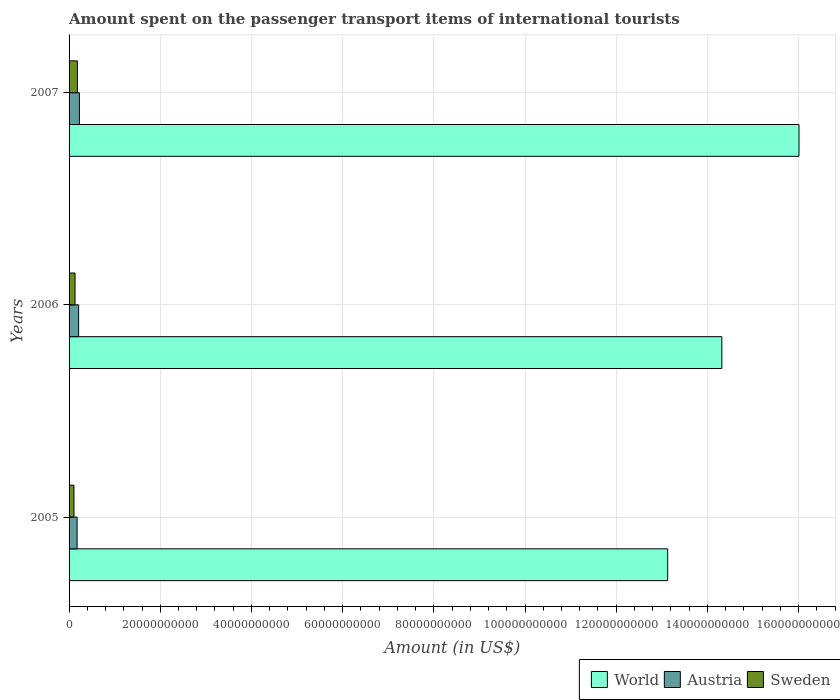How many groups of bars are there?
Give a very brief answer. 3. Are the number of bars per tick equal to the number of legend labels?
Give a very brief answer. Yes. Are the number of bars on each tick of the Y-axis equal?
Provide a short and direct response. Yes. How many bars are there on the 1st tick from the bottom?
Offer a very short reply. 3. In how many cases, is the number of bars for a given year not equal to the number of legend labels?
Ensure brevity in your answer.  0. What is the amount spent on the passenger transport items of international tourists in World in 2006?
Keep it short and to the point. 1.43e+11. Across all years, what is the maximum amount spent on the passenger transport items of international tourists in World?
Your answer should be very brief. 1.60e+11. Across all years, what is the minimum amount spent on the passenger transport items of international tourists in World?
Keep it short and to the point. 1.31e+11. In which year was the amount spent on the passenger transport items of international tourists in Sweden maximum?
Make the answer very short. 2007. What is the total amount spent on the passenger transport items of international tourists in World in the graph?
Your response must be concise. 4.35e+11. What is the difference between the amount spent on the passenger transport items of international tourists in World in 2006 and that in 2007?
Make the answer very short. -1.69e+1. What is the difference between the amount spent on the passenger transport items of international tourists in Sweden in 2005 and the amount spent on the passenger transport items of international tourists in World in 2007?
Make the answer very short. -1.59e+11. What is the average amount spent on the passenger transport items of international tourists in World per year?
Ensure brevity in your answer.  1.45e+11. In the year 2005, what is the difference between the amount spent on the passenger transport items of international tourists in Austria and amount spent on the passenger transport items of international tourists in Sweden?
Offer a terse response. 6.87e+08. In how many years, is the amount spent on the passenger transport items of international tourists in Sweden greater than 100000000000 US$?
Provide a succinct answer. 0. What is the ratio of the amount spent on the passenger transport items of international tourists in World in 2005 to that in 2007?
Offer a very short reply. 0.82. What is the difference between the highest and the second highest amount spent on the passenger transport items of international tourists in World?
Ensure brevity in your answer.  1.69e+1. What is the difference between the highest and the lowest amount spent on the passenger transport items of international tourists in Austria?
Make the answer very short. 5.03e+08. Is the sum of the amount spent on the passenger transport items of international tourists in Austria in 2006 and 2007 greater than the maximum amount spent on the passenger transport items of international tourists in Sweden across all years?
Ensure brevity in your answer.  Yes. Is it the case that in every year, the sum of the amount spent on the passenger transport items of international tourists in Sweden and amount spent on the passenger transport items of international tourists in World is greater than the amount spent on the passenger transport items of international tourists in Austria?
Your answer should be very brief. Yes. Where does the legend appear in the graph?
Offer a very short reply. Bottom right. What is the title of the graph?
Provide a short and direct response. Amount spent on the passenger transport items of international tourists. Does "Ethiopia" appear as one of the legend labels in the graph?
Provide a succinct answer. No. What is the label or title of the Y-axis?
Offer a terse response. Years. What is the Amount (in US$) of World in 2005?
Make the answer very short. 1.31e+11. What is the Amount (in US$) in Austria in 2005?
Provide a succinct answer. 1.76e+09. What is the Amount (in US$) of Sweden in 2005?
Give a very brief answer. 1.07e+09. What is the Amount (in US$) of World in 2006?
Your answer should be very brief. 1.43e+11. What is the Amount (in US$) of Austria in 2006?
Keep it short and to the point. 2.10e+09. What is the Amount (in US$) of Sweden in 2006?
Give a very brief answer. 1.31e+09. What is the Amount (in US$) in World in 2007?
Your answer should be very brief. 1.60e+11. What is the Amount (in US$) in Austria in 2007?
Give a very brief answer. 2.26e+09. What is the Amount (in US$) of Sweden in 2007?
Offer a very short reply. 1.82e+09. Across all years, what is the maximum Amount (in US$) in World?
Ensure brevity in your answer.  1.60e+11. Across all years, what is the maximum Amount (in US$) in Austria?
Your response must be concise. 2.26e+09. Across all years, what is the maximum Amount (in US$) in Sweden?
Your answer should be very brief. 1.82e+09. Across all years, what is the minimum Amount (in US$) in World?
Your answer should be very brief. 1.31e+11. Across all years, what is the minimum Amount (in US$) in Austria?
Provide a succinct answer. 1.76e+09. Across all years, what is the minimum Amount (in US$) in Sweden?
Give a very brief answer. 1.07e+09. What is the total Amount (in US$) of World in the graph?
Your answer should be very brief. 4.35e+11. What is the total Amount (in US$) in Austria in the graph?
Provide a short and direct response. 6.12e+09. What is the total Amount (in US$) in Sweden in the graph?
Offer a very short reply. 4.20e+09. What is the difference between the Amount (in US$) of World in 2005 and that in 2006?
Offer a terse response. -1.19e+1. What is the difference between the Amount (in US$) in Austria in 2005 and that in 2006?
Your response must be concise. -3.34e+08. What is the difference between the Amount (in US$) in Sweden in 2005 and that in 2006?
Your answer should be compact. -2.33e+08. What is the difference between the Amount (in US$) of World in 2005 and that in 2007?
Give a very brief answer. -2.88e+1. What is the difference between the Amount (in US$) in Austria in 2005 and that in 2007?
Ensure brevity in your answer.  -5.03e+08. What is the difference between the Amount (in US$) of Sweden in 2005 and that in 2007?
Keep it short and to the point. -7.50e+08. What is the difference between the Amount (in US$) in World in 2006 and that in 2007?
Offer a terse response. -1.69e+1. What is the difference between the Amount (in US$) in Austria in 2006 and that in 2007?
Your answer should be compact. -1.69e+08. What is the difference between the Amount (in US$) in Sweden in 2006 and that in 2007?
Offer a terse response. -5.17e+08. What is the difference between the Amount (in US$) in World in 2005 and the Amount (in US$) in Austria in 2006?
Your response must be concise. 1.29e+11. What is the difference between the Amount (in US$) of World in 2005 and the Amount (in US$) of Sweden in 2006?
Make the answer very short. 1.30e+11. What is the difference between the Amount (in US$) of Austria in 2005 and the Amount (in US$) of Sweden in 2006?
Give a very brief answer. 4.54e+08. What is the difference between the Amount (in US$) of World in 2005 and the Amount (in US$) of Austria in 2007?
Offer a terse response. 1.29e+11. What is the difference between the Amount (in US$) of World in 2005 and the Amount (in US$) of Sweden in 2007?
Ensure brevity in your answer.  1.29e+11. What is the difference between the Amount (in US$) in Austria in 2005 and the Amount (in US$) in Sweden in 2007?
Provide a succinct answer. -6.30e+07. What is the difference between the Amount (in US$) in World in 2006 and the Amount (in US$) in Austria in 2007?
Offer a terse response. 1.41e+11. What is the difference between the Amount (in US$) of World in 2006 and the Amount (in US$) of Sweden in 2007?
Provide a succinct answer. 1.41e+11. What is the difference between the Amount (in US$) of Austria in 2006 and the Amount (in US$) of Sweden in 2007?
Give a very brief answer. 2.71e+08. What is the average Amount (in US$) of World per year?
Your answer should be very brief. 1.45e+11. What is the average Amount (in US$) in Austria per year?
Your answer should be very brief. 2.04e+09. What is the average Amount (in US$) of Sweden per year?
Provide a short and direct response. 1.40e+09. In the year 2005, what is the difference between the Amount (in US$) of World and Amount (in US$) of Austria?
Your response must be concise. 1.30e+11. In the year 2005, what is the difference between the Amount (in US$) in World and Amount (in US$) in Sweden?
Ensure brevity in your answer.  1.30e+11. In the year 2005, what is the difference between the Amount (in US$) in Austria and Amount (in US$) in Sweden?
Your answer should be compact. 6.87e+08. In the year 2006, what is the difference between the Amount (in US$) in World and Amount (in US$) in Austria?
Keep it short and to the point. 1.41e+11. In the year 2006, what is the difference between the Amount (in US$) in World and Amount (in US$) in Sweden?
Ensure brevity in your answer.  1.42e+11. In the year 2006, what is the difference between the Amount (in US$) in Austria and Amount (in US$) in Sweden?
Give a very brief answer. 7.88e+08. In the year 2007, what is the difference between the Amount (in US$) in World and Amount (in US$) in Austria?
Your response must be concise. 1.58e+11. In the year 2007, what is the difference between the Amount (in US$) in World and Amount (in US$) in Sweden?
Your answer should be very brief. 1.58e+11. In the year 2007, what is the difference between the Amount (in US$) of Austria and Amount (in US$) of Sweden?
Your answer should be very brief. 4.40e+08. What is the ratio of the Amount (in US$) of World in 2005 to that in 2006?
Give a very brief answer. 0.92. What is the ratio of the Amount (in US$) in Austria in 2005 to that in 2006?
Your response must be concise. 0.84. What is the ratio of the Amount (in US$) in Sweden in 2005 to that in 2006?
Offer a terse response. 0.82. What is the ratio of the Amount (in US$) of World in 2005 to that in 2007?
Keep it short and to the point. 0.82. What is the ratio of the Amount (in US$) in Austria in 2005 to that in 2007?
Offer a very short reply. 0.78. What is the ratio of the Amount (in US$) of Sweden in 2005 to that in 2007?
Your answer should be compact. 0.59. What is the ratio of the Amount (in US$) in World in 2006 to that in 2007?
Offer a terse response. 0.89. What is the ratio of the Amount (in US$) of Austria in 2006 to that in 2007?
Make the answer very short. 0.93. What is the ratio of the Amount (in US$) in Sweden in 2006 to that in 2007?
Your answer should be very brief. 0.72. What is the difference between the highest and the second highest Amount (in US$) of World?
Provide a succinct answer. 1.69e+1. What is the difference between the highest and the second highest Amount (in US$) of Austria?
Keep it short and to the point. 1.69e+08. What is the difference between the highest and the second highest Amount (in US$) in Sweden?
Provide a short and direct response. 5.17e+08. What is the difference between the highest and the lowest Amount (in US$) in World?
Provide a short and direct response. 2.88e+1. What is the difference between the highest and the lowest Amount (in US$) of Austria?
Provide a short and direct response. 5.03e+08. What is the difference between the highest and the lowest Amount (in US$) in Sweden?
Give a very brief answer. 7.50e+08. 